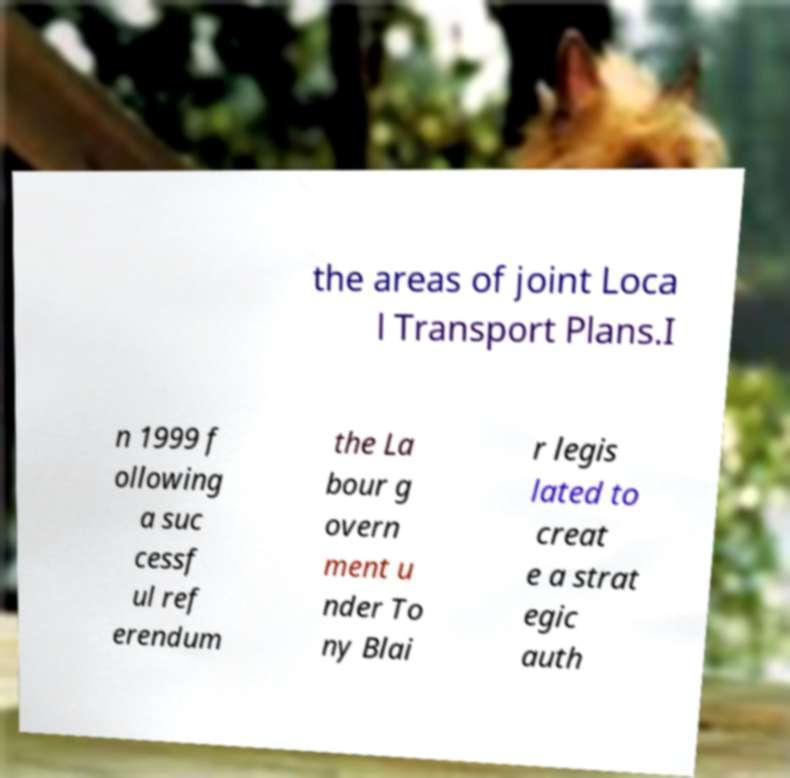Could you assist in decoding the text presented in this image and type it out clearly? the areas of joint Loca l Transport Plans.I n 1999 f ollowing a suc cessf ul ref erendum the La bour g overn ment u nder To ny Blai r legis lated to creat e a strat egic auth 